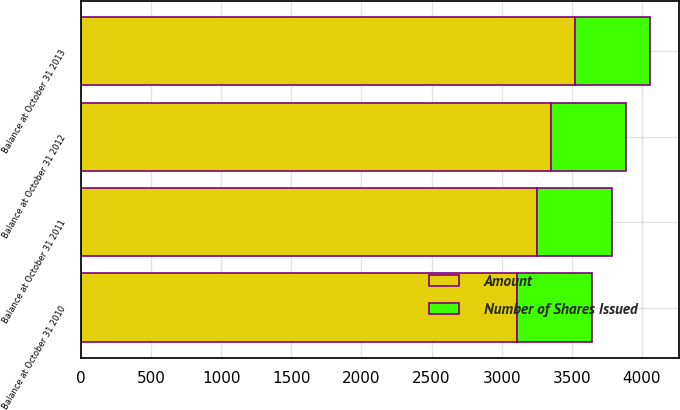Convert chart. <chart><loc_0><loc_0><loc_500><loc_500><stacked_bar_chart><ecel><fcel>Balance at October 31 2010<fcel>Balance at October 31 2011<fcel>Balance at October 31 2012<fcel>Balance at October 31 2013<nl><fcel>Number of Shares Issued<fcel>536.4<fcel>536.4<fcel>536.4<fcel>536.4<nl><fcel>Amount<fcel>3106<fcel>3252<fcel>3352<fcel>3524<nl></chart> 